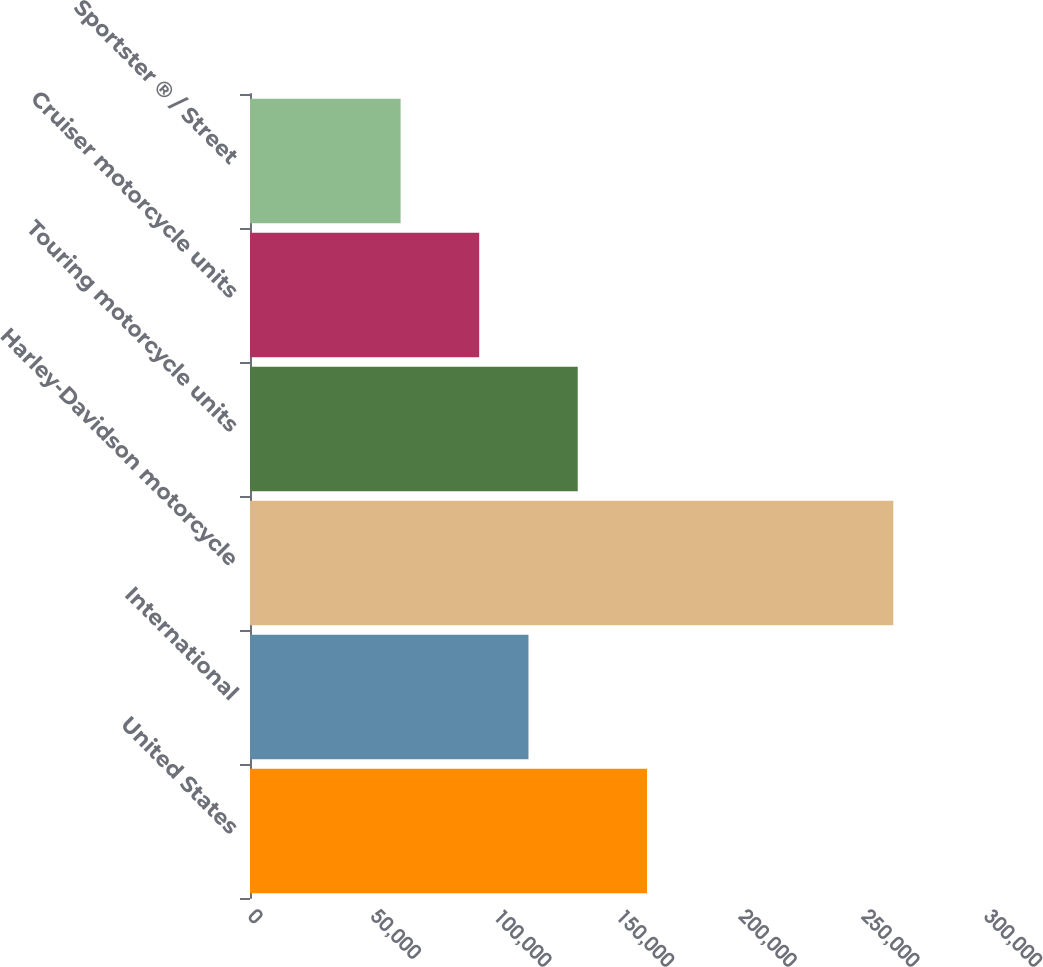Convert chart to OTSL. <chart><loc_0><loc_0><loc_500><loc_500><bar_chart><fcel>United States<fcel>International<fcel>Harley-Davidson motorcycle<fcel>Touring motorcycle units<fcel>Cruiser motorcycle units<fcel>Sportster ® / Street<nl><fcel>161839<fcel>113505<fcel>262221<fcel>133588<fcel>93422<fcel>61389<nl></chart> 